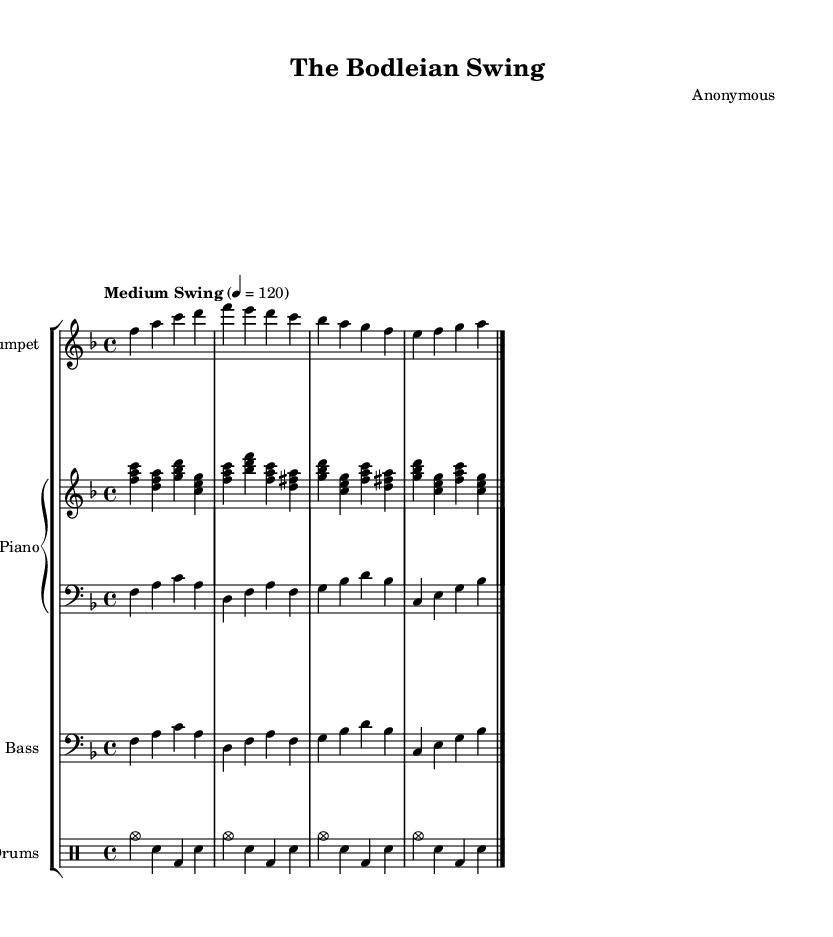What is the key signature of this music? The key signature is F major, which contains one flat (B flat).
Answer: F major What is the time signature of this music? The time signature is 4/4, indicating four beats per measure.
Answer: 4/4 What is the tempo marking of this piece? The tempo marking indicates a "Medium Swing" with a speed of 120 beats per minute.
Answer: Medium Swing Which instrument plays the melody in this piece? The trumpet plays the melody as indicated by the trumpet part at the top.
Answer: Trumpet How many measures are in the trumpet part? By counting the measures in the trumpet section, there are 8 measures in total.
Answer: 8 Which two instruments are part of the piano staff? The piano staff consists of an upper and a lower part, which typically include right-hand (treble) and left-hand (bass) parts.
Answer: Upper and Lower Why does the bass part use a clef different from the trumpet part? The bass part uses a bass clef to indicate lower pitches suitable for the bass instrument, while the trumpet part uses a treble clef for higher pitches.
Answer: Different clefs indicate different pitch ranges 